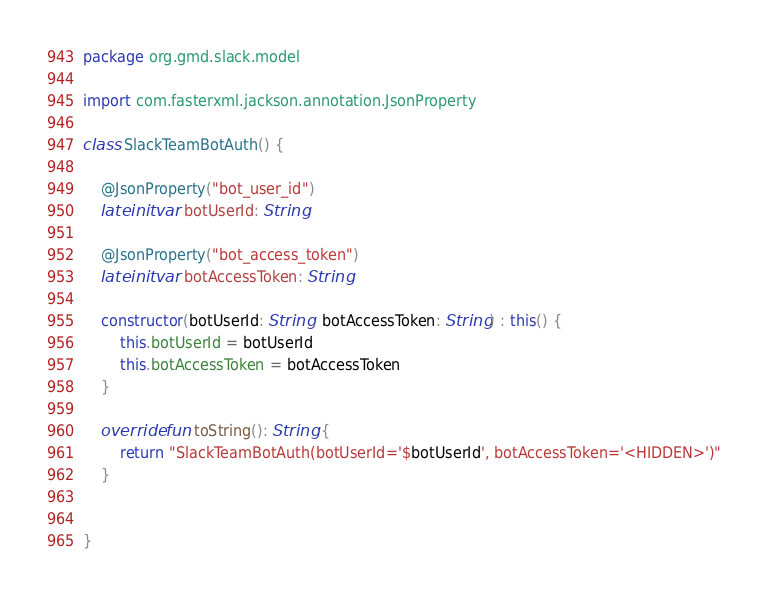<code> <loc_0><loc_0><loc_500><loc_500><_Kotlin_>package org.gmd.slack.model

import com.fasterxml.jackson.annotation.JsonProperty

class SlackTeamBotAuth() {

    @JsonProperty("bot_user_id")
    lateinit var botUserId: String

    @JsonProperty("bot_access_token")
    lateinit var botAccessToken: String
    
    constructor(botUserId: String, botAccessToken: String) : this() {
        this.botUserId = botUserId
        this.botAccessToken = botAccessToken
    }

    override fun toString(): String {
        return "SlackTeamBotAuth(botUserId='$botUserId', botAccessToken='<HIDDEN>')"
    }


}

</code> 